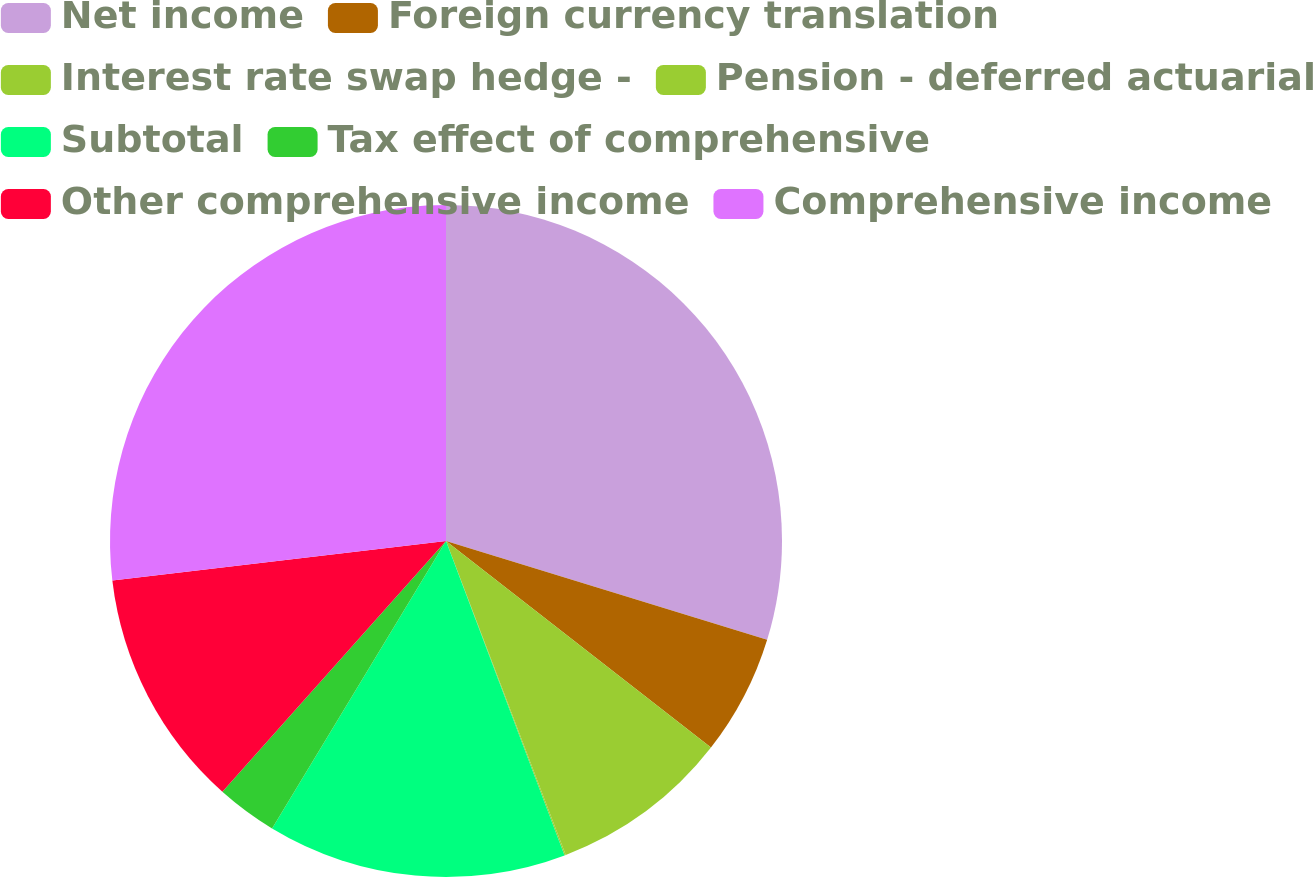Convert chart to OTSL. <chart><loc_0><loc_0><loc_500><loc_500><pie_chart><fcel>Net income<fcel>Foreign currency translation<fcel>Interest rate swap hedge -<fcel>Pension - deferred actuarial<fcel>Subtotal<fcel>Tax effect of comprehensive<fcel>Other comprehensive income<fcel>Comprehensive income<nl><fcel>29.75%<fcel>5.79%<fcel>8.66%<fcel>0.06%<fcel>14.4%<fcel>2.93%<fcel>11.53%<fcel>26.88%<nl></chart> 